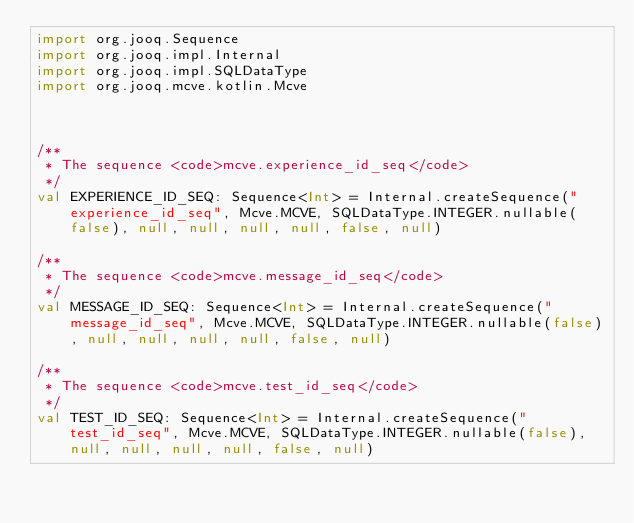<code> <loc_0><loc_0><loc_500><loc_500><_Kotlin_>import org.jooq.Sequence
import org.jooq.impl.Internal
import org.jooq.impl.SQLDataType
import org.jooq.mcve.kotlin.Mcve



/**
 * The sequence <code>mcve.experience_id_seq</code>
 */
val EXPERIENCE_ID_SEQ: Sequence<Int> = Internal.createSequence("experience_id_seq", Mcve.MCVE, SQLDataType.INTEGER.nullable(false), null, null, null, null, false, null)

/**
 * The sequence <code>mcve.message_id_seq</code>
 */
val MESSAGE_ID_SEQ: Sequence<Int> = Internal.createSequence("message_id_seq", Mcve.MCVE, SQLDataType.INTEGER.nullable(false), null, null, null, null, false, null)

/**
 * The sequence <code>mcve.test_id_seq</code>
 */
val TEST_ID_SEQ: Sequence<Int> = Internal.createSequence("test_id_seq", Mcve.MCVE, SQLDataType.INTEGER.nullable(false), null, null, null, null, false, null)
</code> 